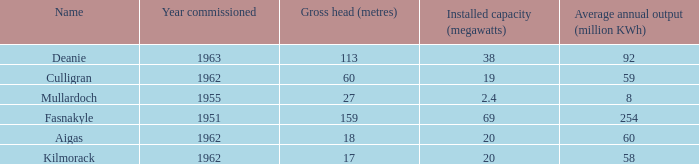What is the Year Commissioned of the power stationo with a Gross head of less than 18? 1962.0. 